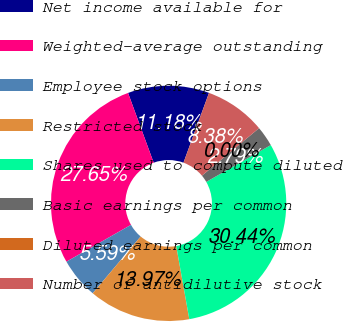Convert chart. <chart><loc_0><loc_0><loc_500><loc_500><pie_chart><fcel>Net income available for<fcel>Weighted-average outstanding<fcel>Employee stock options<fcel>Restricted stock<fcel>Shares used to compute diluted<fcel>Basic earnings per common<fcel>Diluted earnings per common<fcel>Number of antidilutive stock<nl><fcel>11.18%<fcel>27.65%<fcel>5.59%<fcel>13.97%<fcel>30.44%<fcel>2.79%<fcel>0.0%<fcel>8.38%<nl></chart> 